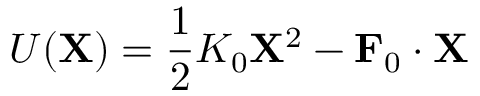Convert formula to latex. <formula><loc_0><loc_0><loc_500><loc_500>U ( X ) = \frac { 1 } { 2 } K _ { 0 } X ^ { 2 } - F _ { 0 } \cdot X</formula> 